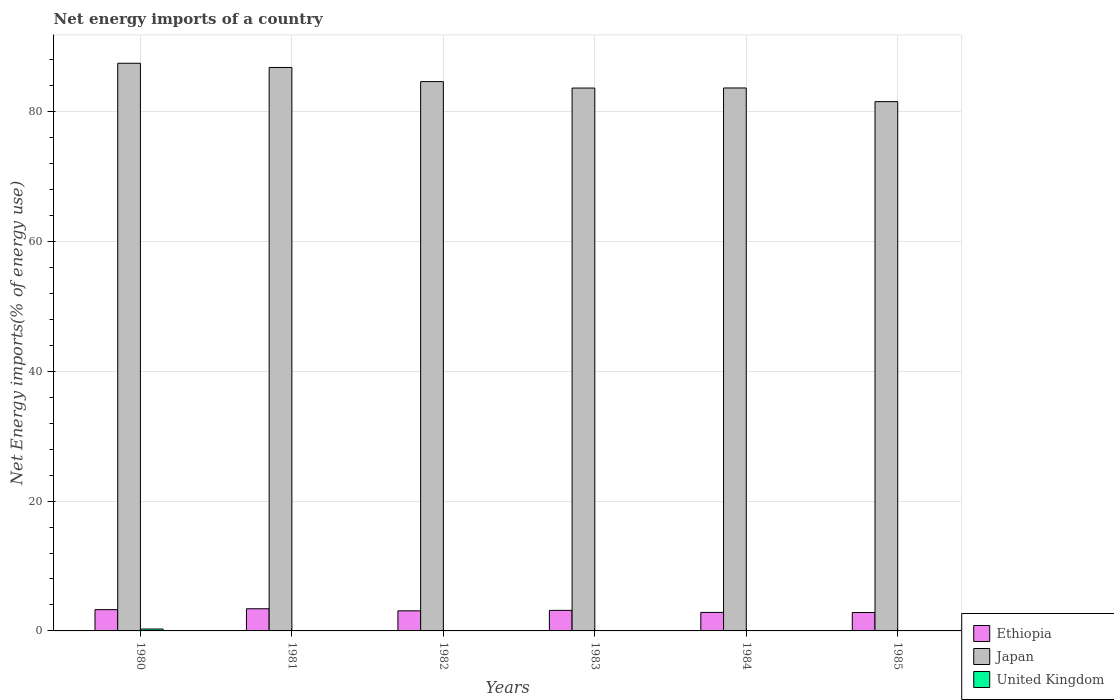Are the number of bars per tick equal to the number of legend labels?
Your answer should be very brief. No. How many bars are there on the 5th tick from the right?
Offer a very short reply. 2. What is the label of the 3rd group of bars from the left?
Give a very brief answer. 1982. In how many cases, is the number of bars for a given year not equal to the number of legend labels?
Your response must be concise. 5. What is the net energy imports in United Kingdom in 1984?
Make the answer very short. 0. Across all years, what is the maximum net energy imports in Ethiopia?
Keep it short and to the point. 3.41. Across all years, what is the minimum net energy imports in Ethiopia?
Your answer should be very brief. 2.84. What is the total net energy imports in United Kingdom in the graph?
Keep it short and to the point. 0.29. What is the difference between the net energy imports in Ethiopia in 1980 and that in 1981?
Your response must be concise. -0.14. What is the difference between the net energy imports in Japan in 1985 and the net energy imports in United Kingdom in 1980?
Ensure brevity in your answer.  81.23. What is the average net energy imports in Japan per year?
Provide a short and direct response. 84.6. In the year 1982, what is the difference between the net energy imports in Ethiopia and net energy imports in Japan?
Your answer should be compact. -81.52. In how many years, is the net energy imports in Japan greater than 40 %?
Give a very brief answer. 6. What is the ratio of the net energy imports in Ethiopia in 1980 to that in 1982?
Provide a short and direct response. 1.06. Is the net energy imports in Japan in 1980 less than that in 1982?
Offer a terse response. No. Is the difference between the net energy imports in Ethiopia in 1980 and 1981 greater than the difference between the net energy imports in Japan in 1980 and 1981?
Your answer should be very brief. No. What is the difference between the highest and the second highest net energy imports in Ethiopia?
Your answer should be compact. 0.14. What is the difference between the highest and the lowest net energy imports in Ethiopia?
Keep it short and to the point. 0.58. In how many years, is the net energy imports in Ethiopia greater than the average net energy imports in Ethiopia taken over all years?
Offer a terse response. 3. Is the sum of the net energy imports in Ethiopia in 1980 and 1983 greater than the maximum net energy imports in Japan across all years?
Offer a terse response. No. Is it the case that in every year, the sum of the net energy imports in Japan and net energy imports in Ethiopia is greater than the net energy imports in United Kingdom?
Ensure brevity in your answer.  Yes. How many bars are there?
Make the answer very short. 13. Are all the bars in the graph horizontal?
Give a very brief answer. No. How many years are there in the graph?
Keep it short and to the point. 6. What is the difference between two consecutive major ticks on the Y-axis?
Provide a succinct answer. 20. Does the graph contain any zero values?
Keep it short and to the point. Yes. Does the graph contain grids?
Provide a succinct answer. Yes. How many legend labels are there?
Ensure brevity in your answer.  3. How are the legend labels stacked?
Offer a terse response. Vertical. What is the title of the graph?
Your response must be concise. Net energy imports of a country. What is the label or title of the Y-axis?
Your answer should be compact. Net Energy imports(% of energy use). What is the Net Energy imports(% of energy use) of Ethiopia in 1980?
Make the answer very short. 3.28. What is the Net Energy imports(% of energy use) in Japan in 1980?
Your answer should be very brief. 87.43. What is the Net Energy imports(% of energy use) in United Kingdom in 1980?
Provide a succinct answer. 0.29. What is the Net Energy imports(% of energy use) of Ethiopia in 1981?
Your response must be concise. 3.41. What is the Net Energy imports(% of energy use) in Japan in 1981?
Make the answer very short. 86.79. What is the Net Energy imports(% of energy use) of United Kingdom in 1981?
Keep it short and to the point. 0. What is the Net Energy imports(% of energy use) in Ethiopia in 1982?
Keep it short and to the point. 3.09. What is the Net Energy imports(% of energy use) in Japan in 1982?
Your answer should be compact. 84.61. What is the Net Energy imports(% of energy use) of United Kingdom in 1982?
Offer a very short reply. 0. What is the Net Energy imports(% of energy use) in Ethiopia in 1983?
Your answer should be very brief. 3.16. What is the Net Energy imports(% of energy use) in Japan in 1983?
Your response must be concise. 83.62. What is the Net Energy imports(% of energy use) of Ethiopia in 1984?
Ensure brevity in your answer.  2.85. What is the Net Energy imports(% of energy use) in Japan in 1984?
Your answer should be very brief. 83.63. What is the Net Energy imports(% of energy use) in United Kingdom in 1984?
Ensure brevity in your answer.  0. What is the Net Energy imports(% of energy use) of Ethiopia in 1985?
Ensure brevity in your answer.  2.84. What is the Net Energy imports(% of energy use) in Japan in 1985?
Offer a terse response. 81.52. Across all years, what is the maximum Net Energy imports(% of energy use) in Ethiopia?
Give a very brief answer. 3.41. Across all years, what is the maximum Net Energy imports(% of energy use) in Japan?
Provide a short and direct response. 87.43. Across all years, what is the maximum Net Energy imports(% of energy use) in United Kingdom?
Your answer should be very brief. 0.29. Across all years, what is the minimum Net Energy imports(% of energy use) in Ethiopia?
Keep it short and to the point. 2.84. Across all years, what is the minimum Net Energy imports(% of energy use) in Japan?
Your answer should be compact. 81.52. Across all years, what is the minimum Net Energy imports(% of energy use) of United Kingdom?
Provide a short and direct response. 0. What is the total Net Energy imports(% of energy use) in Ethiopia in the graph?
Provide a succinct answer. 18.63. What is the total Net Energy imports(% of energy use) in Japan in the graph?
Provide a short and direct response. 507.6. What is the total Net Energy imports(% of energy use) of United Kingdom in the graph?
Offer a terse response. 0.29. What is the difference between the Net Energy imports(% of energy use) of Ethiopia in 1980 and that in 1981?
Ensure brevity in your answer.  -0.14. What is the difference between the Net Energy imports(% of energy use) of Japan in 1980 and that in 1981?
Offer a very short reply. 0.65. What is the difference between the Net Energy imports(% of energy use) of Ethiopia in 1980 and that in 1982?
Your answer should be very brief. 0.18. What is the difference between the Net Energy imports(% of energy use) in Japan in 1980 and that in 1982?
Offer a terse response. 2.83. What is the difference between the Net Energy imports(% of energy use) in Ethiopia in 1980 and that in 1983?
Make the answer very short. 0.11. What is the difference between the Net Energy imports(% of energy use) in Japan in 1980 and that in 1983?
Make the answer very short. 3.82. What is the difference between the Net Energy imports(% of energy use) in Ethiopia in 1980 and that in 1984?
Your answer should be very brief. 0.42. What is the difference between the Net Energy imports(% of energy use) of Japan in 1980 and that in 1984?
Your answer should be compact. 3.81. What is the difference between the Net Energy imports(% of energy use) of Ethiopia in 1980 and that in 1985?
Give a very brief answer. 0.44. What is the difference between the Net Energy imports(% of energy use) in Japan in 1980 and that in 1985?
Offer a terse response. 5.91. What is the difference between the Net Energy imports(% of energy use) of Ethiopia in 1981 and that in 1982?
Your answer should be compact. 0.32. What is the difference between the Net Energy imports(% of energy use) in Japan in 1981 and that in 1982?
Ensure brevity in your answer.  2.18. What is the difference between the Net Energy imports(% of energy use) in Ethiopia in 1981 and that in 1983?
Give a very brief answer. 0.25. What is the difference between the Net Energy imports(% of energy use) in Japan in 1981 and that in 1983?
Offer a very short reply. 3.17. What is the difference between the Net Energy imports(% of energy use) of Ethiopia in 1981 and that in 1984?
Make the answer very short. 0.56. What is the difference between the Net Energy imports(% of energy use) in Japan in 1981 and that in 1984?
Provide a short and direct response. 3.16. What is the difference between the Net Energy imports(% of energy use) in Ethiopia in 1981 and that in 1985?
Make the answer very short. 0.58. What is the difference between the Net Energy imports(% of energy use) of Japan in 1981 and that in 1985?
Provide a short and direct response. 5.26. What is the difference between the Net Energy imports(% of energy use) of Ethiopia in 1982 and that in 1983?
Your answer should be compact. -0.07. What is the difference between the Net Energy imports(% of energy use) in Ethiopia in 1982 and that in 1984?
Provide a short and direct response. 0.24. What is the difference between the Net Energy imports(% of energy use) in Japan in 1982 and that in 1984?
Provide a short and direct response. 0.98. What is the difference between the Net Energy imports(% of energy use) in Ethiopia in 1982 and that in 1985?
Offer a very short reply. 0.26. What is the difference between the Net Energy imports(% of energy use) of Japan in 1982 and that in 1985?
Your answer should be compact. 3.08. What is the difference between the Net Energy imports(% of energy use) in Ethiopia in 1983 and that in 1984?
Offer a terse response. 0.31. What is the difference between the Net Energy imports(% of energy use) of Japan in 1983 and that in 1984?
Keep it short and to the point. -0.01. What is the difference between the Net Energy imports(% of energy use) of Ethiopia in 1983 and that in 1985?
Your response must be concise. 0.33. What is the difference between the Net Energy imports(% of energy use) of Japan in 1983 and that in 1985?
Your response must be concise. 2.09. What is the difference between the Net Energy imports(% of energy use) in Ethiopia in 1984 and that in 1985?
Ensure brevity in your answer.  0.02. What is the difference between the Net Energy imports(% of energy use) in Japan in 1984 and that in 1985?
Provide a short and direct response. 2.1. What is the difference between the Net Energy imports(% of energy use) of Ethiopia in 1980 and the Net Energy imports(% of energy use) of Japan in 1981?
Offer a very short reply. -83.51. What is the difference between the Net Energy imports(% of energy use) of Ethiopia in 1980 and the Net Energy imports(% of energy use) of Japan in 1982?
Make the answer very short. -81.33. What is the difference between the Net Energy imports(% of energy use) of Ethiopia in 1980 and the Net Energy imports(% of energy use) of Japan in 1983?
Give a very brief answer. -80.34. What is the difference between the Net Energy imports(% of energy use) of Ethiopia in 1980 and the Net Energy imports(% of energy use) of Japan in 1984?
Your answer should be very brief. -80.35. What is the difference between the Net Energy imports(% of energy use) of Ethiopia in 1980 and the Net Energy imports(% of energy use) of Japan in 1985?
Offer a very short reply. -78.25. What is the difference between the Net Energy imports(% of energy use) of Ethiopia in 1981 and the Net Energy imports(% of energy use) of Japan in 1982?
Ensure brevity in your answer.  -81.2. What is the difference between the Net Energy imports(% of energy use) in Ethiopia in 1981 and the Net Energy imports(% of energy use) in Japan in 1983?
Provide a succinct answer. -80.2. What is the difference between the Net Energy imports(% of energy use) of Ethiopia in 1981 and the Net Energy imports(% of energy use) of Japan in 1984?
Your answer should be very brief. -80.22. What is the difference between the Net Energy imports(% of energy use) in Ethiopia in 1981 and the Net Energy imports(% of energy use) in Japan in 1985?
Offer a very short reply. -78.11. What is the difference between the Net Energy imports(% of energy use) in Ethiopia in 1982 and the Net Energy imports(% of energy use) in Japan in 1983?
Ensure brevity in your answer.  -80.52. What is the difference between the Net Energy imports(% of energy use) in Ethiopia in 1982 and the Net Energy imports(% of energy use) in Japan in 1984?
Provide a succinct answer. -80.54. What is the difference between the Net Energy imports(% of energy use) of Ethiopia in 1982 and the Net Energy imports(% of energy use) of Japan in 1985?
Make the answer very short. -78.43. What is the difference between the Net Energy imports(% of energy use) of Ethiopia in 1983 and the Net Energy imports(% of energy use) of Japan in 1984?
Ensure brevity in your answer.  -80.47. What is the difference between the Net Energy imports(% of energy use) in Ethiopia in 1983 and the Net Energy imports(% of energy use) in Japan in 1985?
Offer a very short reply. -78.36. What is the difference between the Net Energy imports(% of energy use) of Ethiopia in 1984 and the Net Energy imports(% of energy use) of Japan in 1985?
Keep it short and to the point. -78.67. What is the average Net Energy imports(% of energy use) of Ethiopia per year?
Provide a short and direct response. 3.11. What is the average Net Energy imports(% of energy use) of Japan per year?
Your answer should be compact. 84.6. What is the average Net Energy imports(% of energy use) of United Kingdom per year?
Offer a very short reply. 0.05. In the year 1980, what is the difference between the Net Energy imports(% of energy use) in Ethiopia and Net Energy imports(% of energy use) in Japan?
Give a very brief answer. -84.16. In the year 1980, what is the difference between the Net Energy imports(% of energy use) of Ethiopia and Net Energy imports(% of energy use) of United Kingdom?
Your response must be concise. 2.98. In the year 1980, what is the difference between the Net Energy imports(% of energy use) of Japan and Net Energy imports(% of energy use) of United Kingdom?
Offer a terse response. 87.14. In the year 1981, what is the difference between the Net Energy imports(% of energy use) of Ethiopia and Net Energy imports(% of energy use) of Japan?
Give a very brief answer. -83.37. In the year 1982, what is the difference between the Net Energy imports(% of energy use) in Ethiopia and Net Energy imports(% of energy use) in Japan?
Keep it short and to the point. -81.52. In the year 1983, what is the difference between the Net Energy imports(% of energy use) of Ethiopia and Net Energy imports(% of energy use) of Japan?
Make the answer very short. -80.45. In the year 1984, what is the difference between the Net Energy imports(% of energy use) in Ethiopia and Net Energy imports(% of energy use) in Japan?
Keep it short and to the point. -80.78. In the year 1985, what is the difference between the Net Energy imports(% of energy use) in Ethiopia and Net Energy imports(% of energy use) in Japan?
Keep it short and to the point. -78.69. What is the ratio of the Net Energy imports(% of energy use) in Ethiopia in 1980 to that in 1981?
Offer a very short reply. 0.96. What is the ratio of the Net Energy imports(% of energy use) of Japan in 1980 to that in 1981?
Offer a terse response. 1.01. What is the ratio of the Net Energy imports(% of energy use) in Ethiopia in 1980 to that in 1982?
Give a very brief answer. 1.06. What is the ratio of the Net Energy imports(% of energy use) of Japan in 1980 to that in 1982?
Your answer should be compact. 1.03. What is the ratio of the Net Energy imports(% of energy use) of Ethiopia in 1980 to that in 1983?
Keep it short and to the point. 1.04. What is the ratio of the Net Energy imports(% of energy use) of Japan in 1980 to that in 1983?
Provide a short and direct response. 1.05. What is the ratio of the Net Energy imports(% of energy use) in Ethiopia in 1980 to that in 1984?
Provide a succinct answer. 1.15. What is the ratio of the Net Energy imports(% of energy use) of Japan in 1980 to that in 1984?
Provide a short and direct response. 1.05. What is the ratio of the Net Energy imports(% of energy use) of Ethiopia in 1980 to that in 1985?
Give a very brief answer. 1.16. What is the ratio of the Net Energy imports(% of energy use) in Japan in 1980 to that in 1985?
Offer a terse response. 1.07. What is the ratio of the Net Energy imports(% of energy use) in Ethiopia in 1981 to that in 1982?
Offer a terse response. 1.1. What is the ratio of the Net Energy imports(% of energy use) in Japan in 1981 to that in 1982?
Keep it short and to the point. 1.03. What is the ratio of the Net Energy imports(% of energy use) of Ethiopia in 1981 to that in 1983?
Offer a terse response. 1.08. What is the ratio of the Net Energy imports(% of energy use) of Japan in 1981 to that in 1983?
Offer a terse response. 1.04. What is the ratio of the Net Energy imports(% of energy use) in Ethiopia in 1981 to that in 1984?
Your answer should be compact. 1.2. What is the ratio of the Net Energy imports(% of energy use) of Japan in 1981 to that in 1984?
Give a very brief answer. 1.04. What is the ratio of the Net Energy imports(% of energy use) in Ethiopia in 1981 to that in 1985?
Your answer should be very brief. 1.2. What is the ratio of the Net Energy imports(% of energy use) of Japan in 1981 to that in 1985?
Your answer should be compact. 1.06. What is the ratio of the Net Energy imports(% of energy use) in Ethiopia in 1982 to that in 1983?
Your answer should be very brief. 0.98. What is the ratio of the Net Energy imports(% of energy use) in Japan in 1982 to that in 1983?
Your answer should be very brief. 1.01. What is the ratio of the Net Energy imports(% of energy use) of Ethiopia in 1982 to that in 1984?
Your answer should be very brief. 1.08. What is the ratio of the Net Energy imports(% of energy use) in Japan in 1982 to that in 1984?
Your response must be concise. 1.01. What is the ratio of the Net Energy imports(% of energy use) in Ethiopia in 1982 to that in 1985?
Keep it short and to the point. 1.09. What is the ratio of the Net Energy imports(% of energy use) in Japan in 1982 to that in 1985?
Keep it short and to the point. 1.04. What is the ratio of the Net Energy imports(% of energy use) of Ethiopia in 1983 to that in 1984?
Keep it short and to the point. 1.11. What is the ratio of the Net Energy imports(% of energy use) in Ethiopia in 1983 to that in 1985?
Your answer should be compact. 1.12. What is the ratio of the Net Energy imports(% of energy use) in Japan in 1983 to that in 1985?
Keep it short and to the point. 1.03. What is the ratio of the Net Energy imports(% of energy use) in Japan in 1984 to that in 1985?
Keep it short and to the point. 1.03. What is the difference between the highest and the second highest Net Energy imports(% of energy use) of Ethiopia?
Provide a succinct answer. 0.14. What is the difference between the highest and the second highest Net Energy imports(% of energy use) in Japan?
Your answer should be very brief. 0.65. What is the difference between the highest and the lowest Net Energy imports(% of energy use) of Ethiopia?
Your answer should be compact. 0.58. What is the difference between the highest and the lowest Net Energy imports(% of energy use) in Japan?
Offer a terse response. 5.91. What is the difference between the highest and the lowest Net Energy imports(% of energy use) in United Kingdom?
Ensure brevity in your answer.  0.29. 